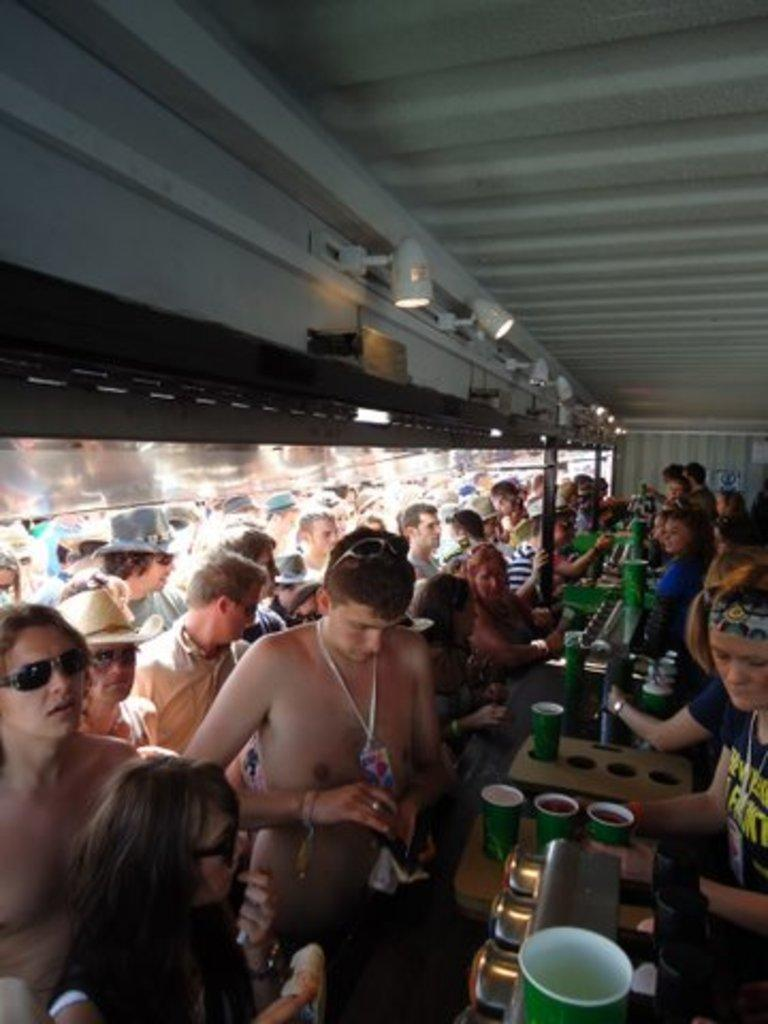Who is the main subject in the middle of the image? There is a man in the middle of the image. Are there any other people present in the image? Yes, there are other people standing in the image. Can you describe the girl on the right side of the image? The girl is wearing a t-shirt. What type of prose is being recited by the man in the image? There is no indication in the image that the man is reciting any prose. Can you see a bucket in the image? There is no bucket present in the image. 